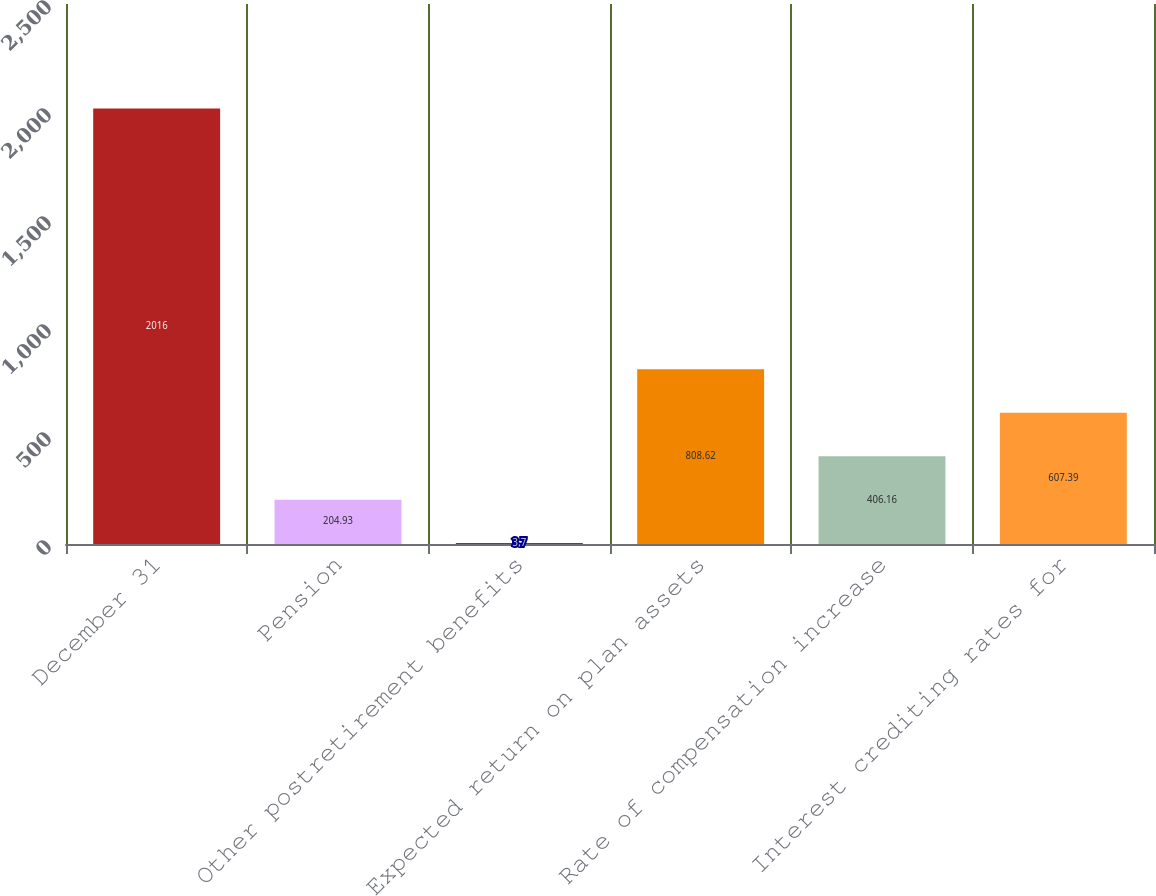<chart> <loc_0><loc_0><loc_500><loc_500><bar_chart><fcel>December 31<fcel>Pension<fcel>Other postretirement benefits<fcel>Expected return on plan assets<fcel>Rate of compensation increase<fcel>Interest crediting rates for<nl><fcel>2016<fcel>204.93<fcel>3.7<fcel>808.62<fcel>406.16<fcel>607.39<nl></chart> 